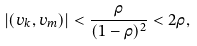<formula> <loc_0><loc_0><loc_500><loc_500>| ( v _ { k } , v _ { m } ) | < \frac { \rho } { ( 1 - \rho ) ^ { 2 } } < 2 \rho ,</formula> 